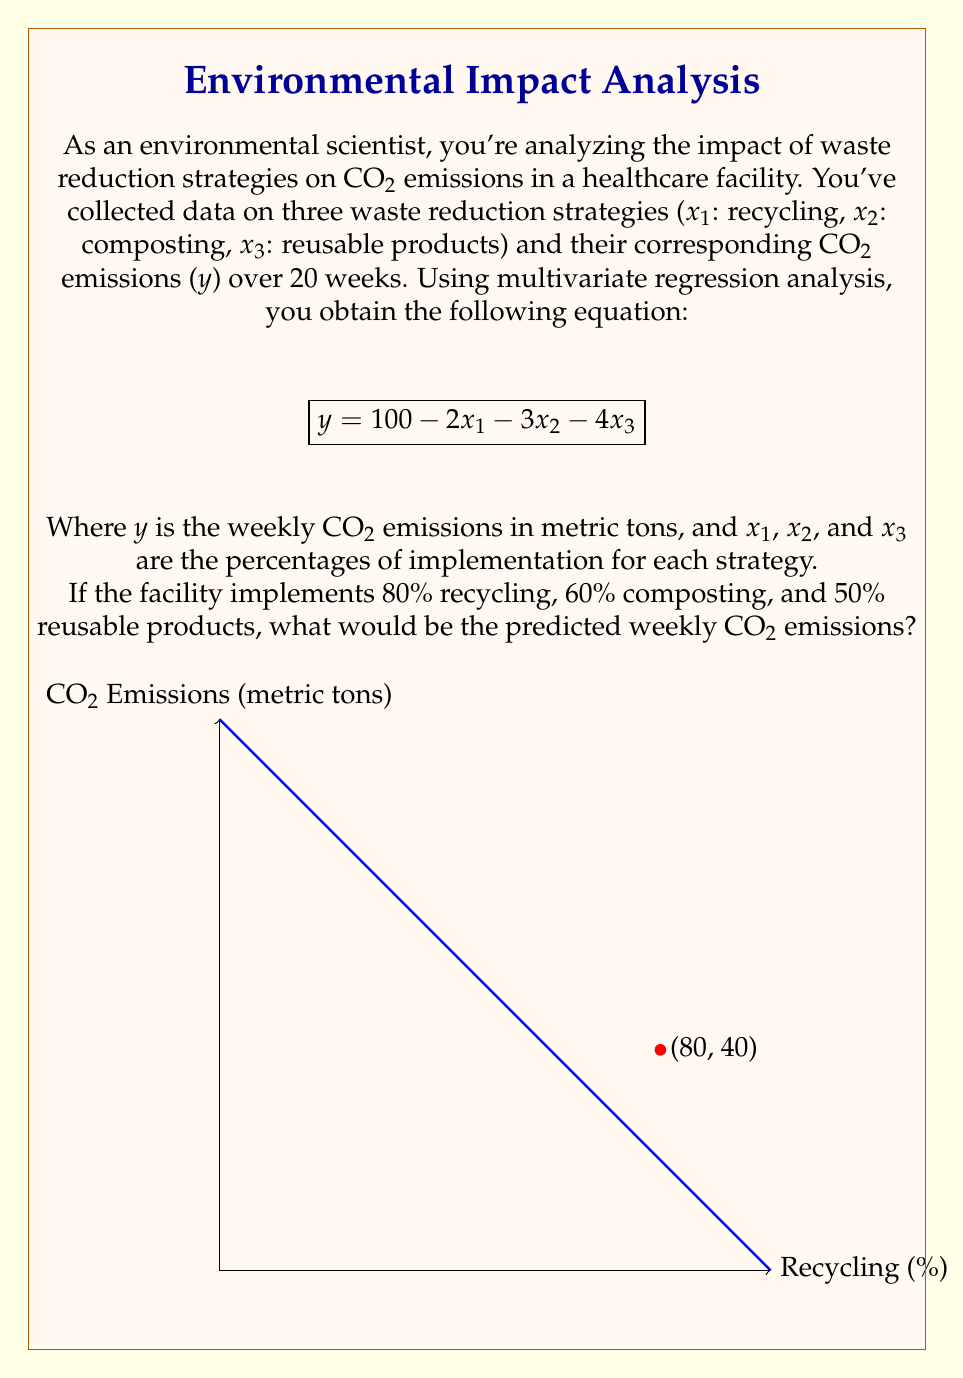Help me with this question. To solve this problem, we'll follow these steps:

1) We have the multivariate regression equation:
   $$y = 100 - 2x_1 - 3x_2 - 4x_3$$

2) We're given the implementation percentages:
   $x_1$ (recycling) = 80%
   $x_2$ (composting) = 60%
   $x_3$ (reusable products) = 50%

3) Let's substitute these values into our equation:
   $$y = 100 - 2(80) - 3(60) - 4(50)$$

4) Now, let's calculate each term:
   $$y = 100 - 160 - 180 - 200$$

5) Simplify:
   $$y = 100 - 540 = -440$$

6) However, CO2 emissions can't be negative. This result suggests that the model predicts zero emissions with these high implementation rates. In practice, we would cap the result at 0.

Therefore, the predicted weekly CO2 emissions would be 0 metric tons.
Answer: 0 metric tons 